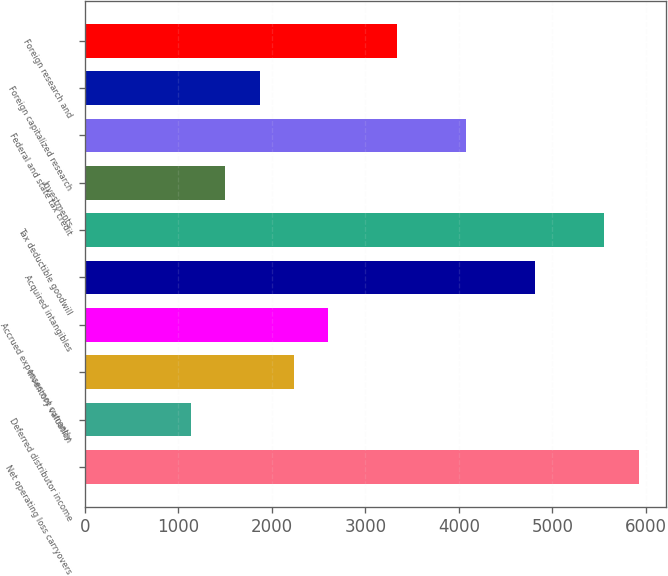<chart> <loc_0><loc_0><loc_500><loc_500><bar_chart><fcel>Net operating loss carryovers<fcel>Deferred distributor income<fcel>Inventory valuation<fcel>Accrued expenses not currently<fcel>Acquired intangibles<fcel>Tax deductible goodwill<fcel>Investments<fcel>Federal and state tax credit<fcel>Foreign capitalized research<fcel>Foreign research and<nl><fcel>5925.4<fcel>1129.7<fcel>2236.4<fcel>2605.3<fcel>4818.7<fcel>5556.5<fcel>1498.6<fcel>4080.9<fcel>1867.5<fcel>3343.1<nl></chart> 